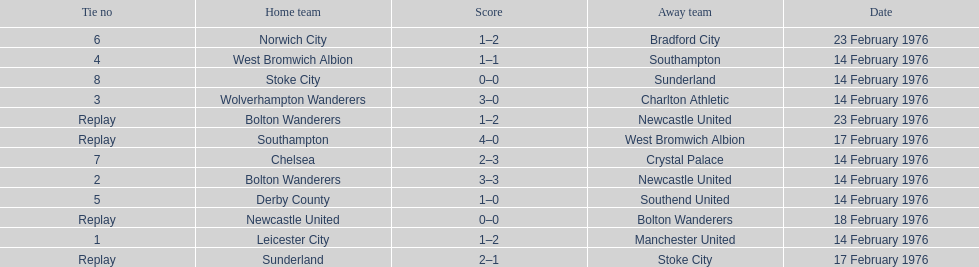What was the goal difference in the game on february 18th? 0. 